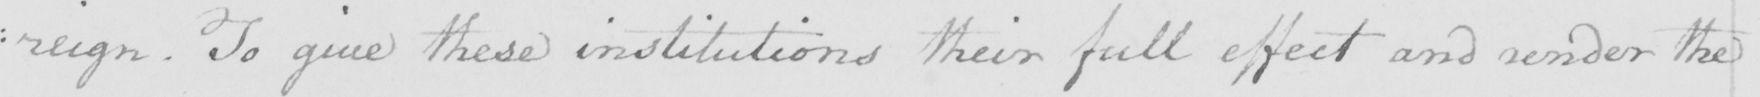What is written in this line of handwriting? :reign. To give these institutions their full effect and render the 